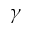Convert formula to latex. <formula><loc_0><loc_0><loc_500><loc_500>\gamma</formula> 